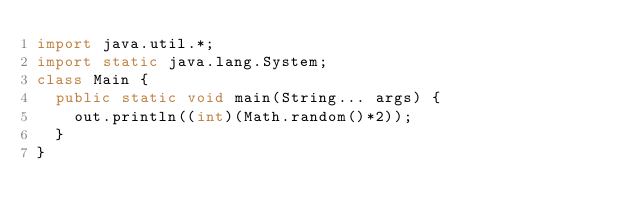Convert code to text. <code><loc_0><loc_0><loc_500><loc_500><_Java_>import java.util.*;
import static java.lang.System;
class Main {
  public static void main(String... args) {
    out.println((int)(Math.random()*2));
  }
}
</code> 